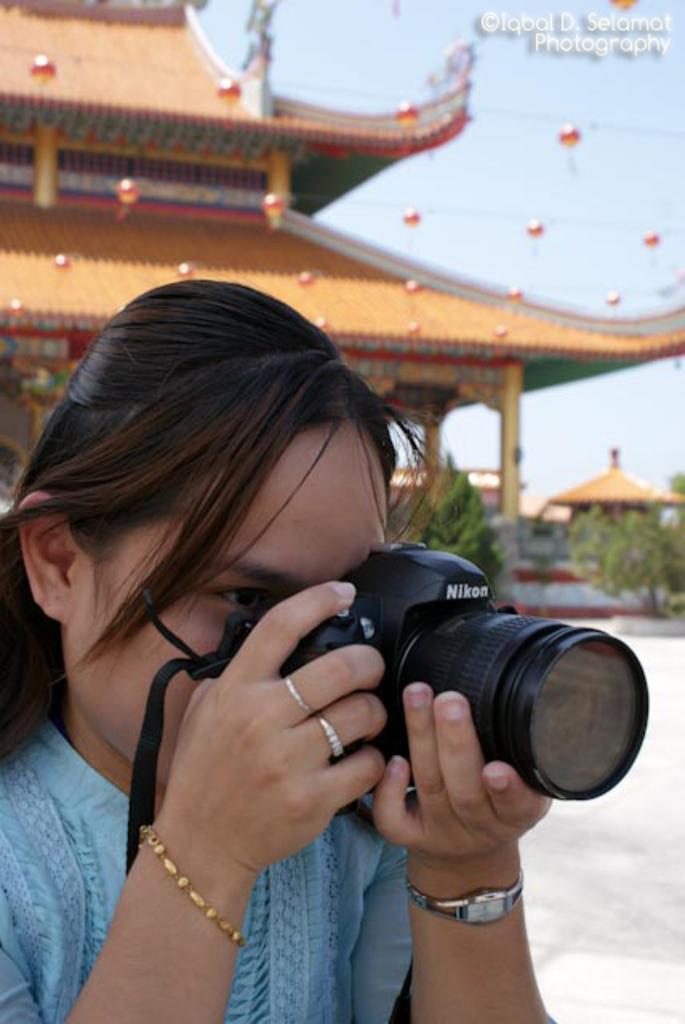Please provide a concise description of this image. On the left there is a woman she wear blue dress and watch ,her hair is short she holds a camera. In the background there is a building ,plants and sky. 